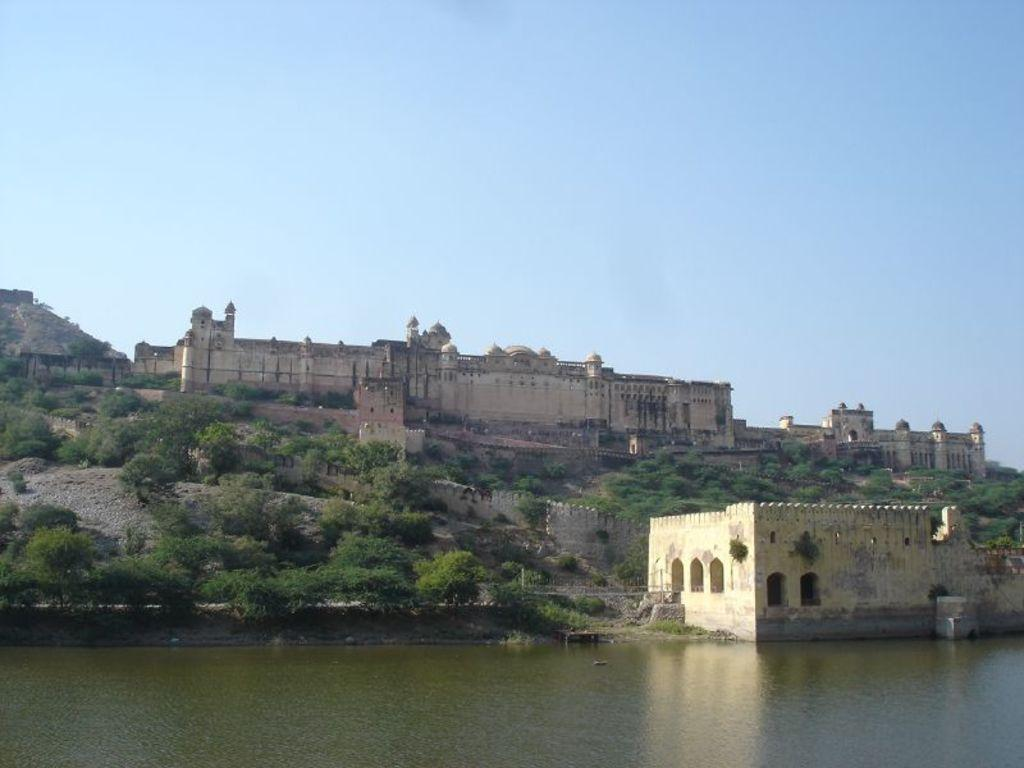What type of structure is present in the image? There is a monument in the image. What other type of building can be seen in the image? There is a house in the image. What natural elements are present in the image? There are trees and water visible in the image. What is the color of the sky in the image? The sky is blue in the image. What is your opinion on the garden in the image? There is no garden present in the image, so it is not possible to provide an opinion on it. How many dimes can be seen in the image? There are no dimes present in the image. 